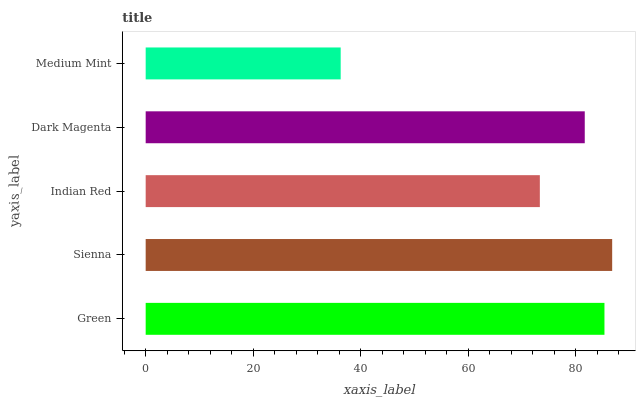Is Medium Mint the minimum?
Answer yes or no. Yes. Is Sienna the maximum?
Answer yes or no. Yes. Is Indian Red the minimum?
Answer yes or no. No. Is Indian Red the maximum?
Answer yes or no. No. Is Sienna greater than Indian Red?
Answer yes or no. Yes. Is Indian Red less than Sienna?
Answer yes or no. Yes. Is Indian Red greater than Sienna?
Answer yes or no. No. Is Sienna less than Indian Red?
Answer yes or no. No. Is Dark Magenta the high median?
Answer yes or no. Yes. Is Dark Magenta the low median?
Answer yes or no. Yes. Is Indian Red the high median?
Answer yes or no. No. Is Sienna the low median?
Answer yes or no. No. 